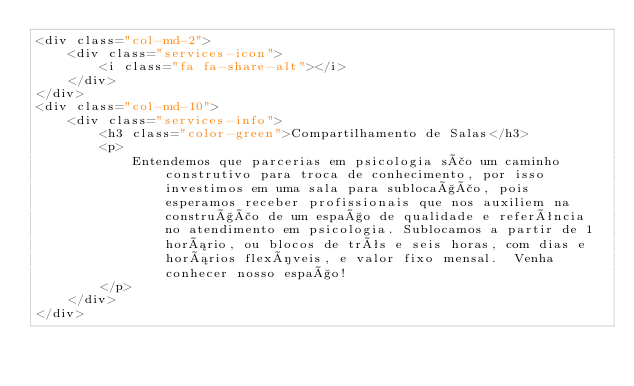<code> <loc_0><loc_0><loc_500><loc_500><_PHP_><div class="col-md-2">
    <div class="services-icon">
        <i class="fa fa-share-alt"></i>
    </div>
</div>
<div class="col-md-10">
    <div class="services-info">
        <h3 class="color-green">Compartilhamento de Salas</h3>
        <p>
            Entendemos que parcerias em psicologia são um caminho construtivo para troca de conhecimento, por isso investimos em uma sala para sublocação, pois esperamos receber profissionais que nos auxiliem na construção de um espaço de qualidade e referência no atendimento em psicologia. Sublocamos a partir de 1 horário, ou blocos de três e seis horas, com dias e horários flexíveis, e valor fixo mensal.  Venha conhecer nosso espaço!
        </p>
    </div>
</div>
</code> 